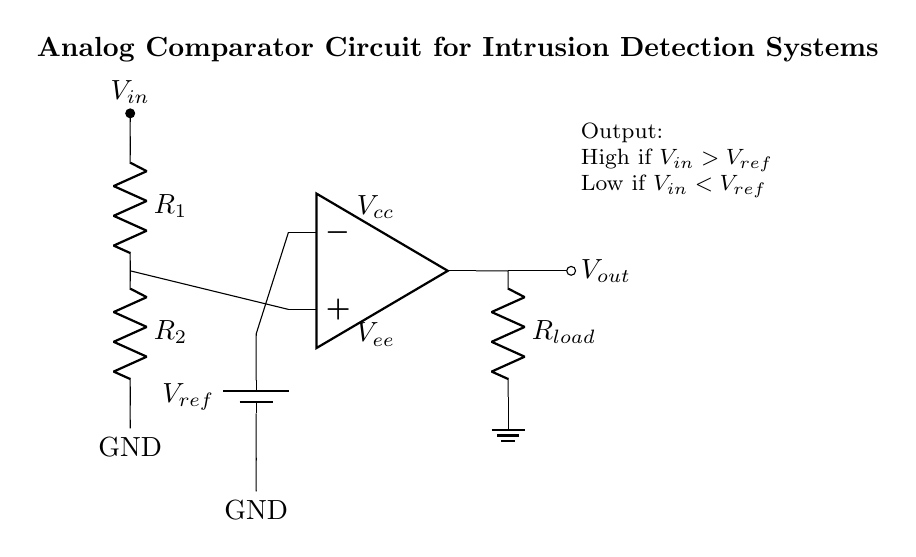What is the purpose of the op-amp in this circuit? The op-amp functions as a comparator that compares the input voltage with a reference voltage, determining whether the output should be high or low based on this comparison.
Answer: Comparator What are the resistance values labeled in the circuit? The circuit shows two resistors labeled as R1 and R2; however, their specific resistance values are not provided in the diagram and need to be determined or specified elsewhere.
Answer: R1 and R2 What happens to the output voltage when the input voltage is greater than the reference voltage? When the input voltage exceeds the reference voltage, the op-amp output switches to a high state, indicating a positive comparison.
Answer: High What is the value of the reference voltage? The diagram shows a reference voltage labeled as Vref, but its actual value is not indicated in the circuit and should be provided separately in specifications.
Answer: Vref How is the output connected to the load? The output of the op-amp connects to the load through a resistor labeled as Rload, completing the circuit to ground.
Answer: Through Rload If the input voltage is less than the reference voltage, what happens to the output? In this scenario, the output from the op-amp goes low, signaling that the input condition is not met, which would typically indicate no intrusion detected if used in detection systems.
Answer: Low 